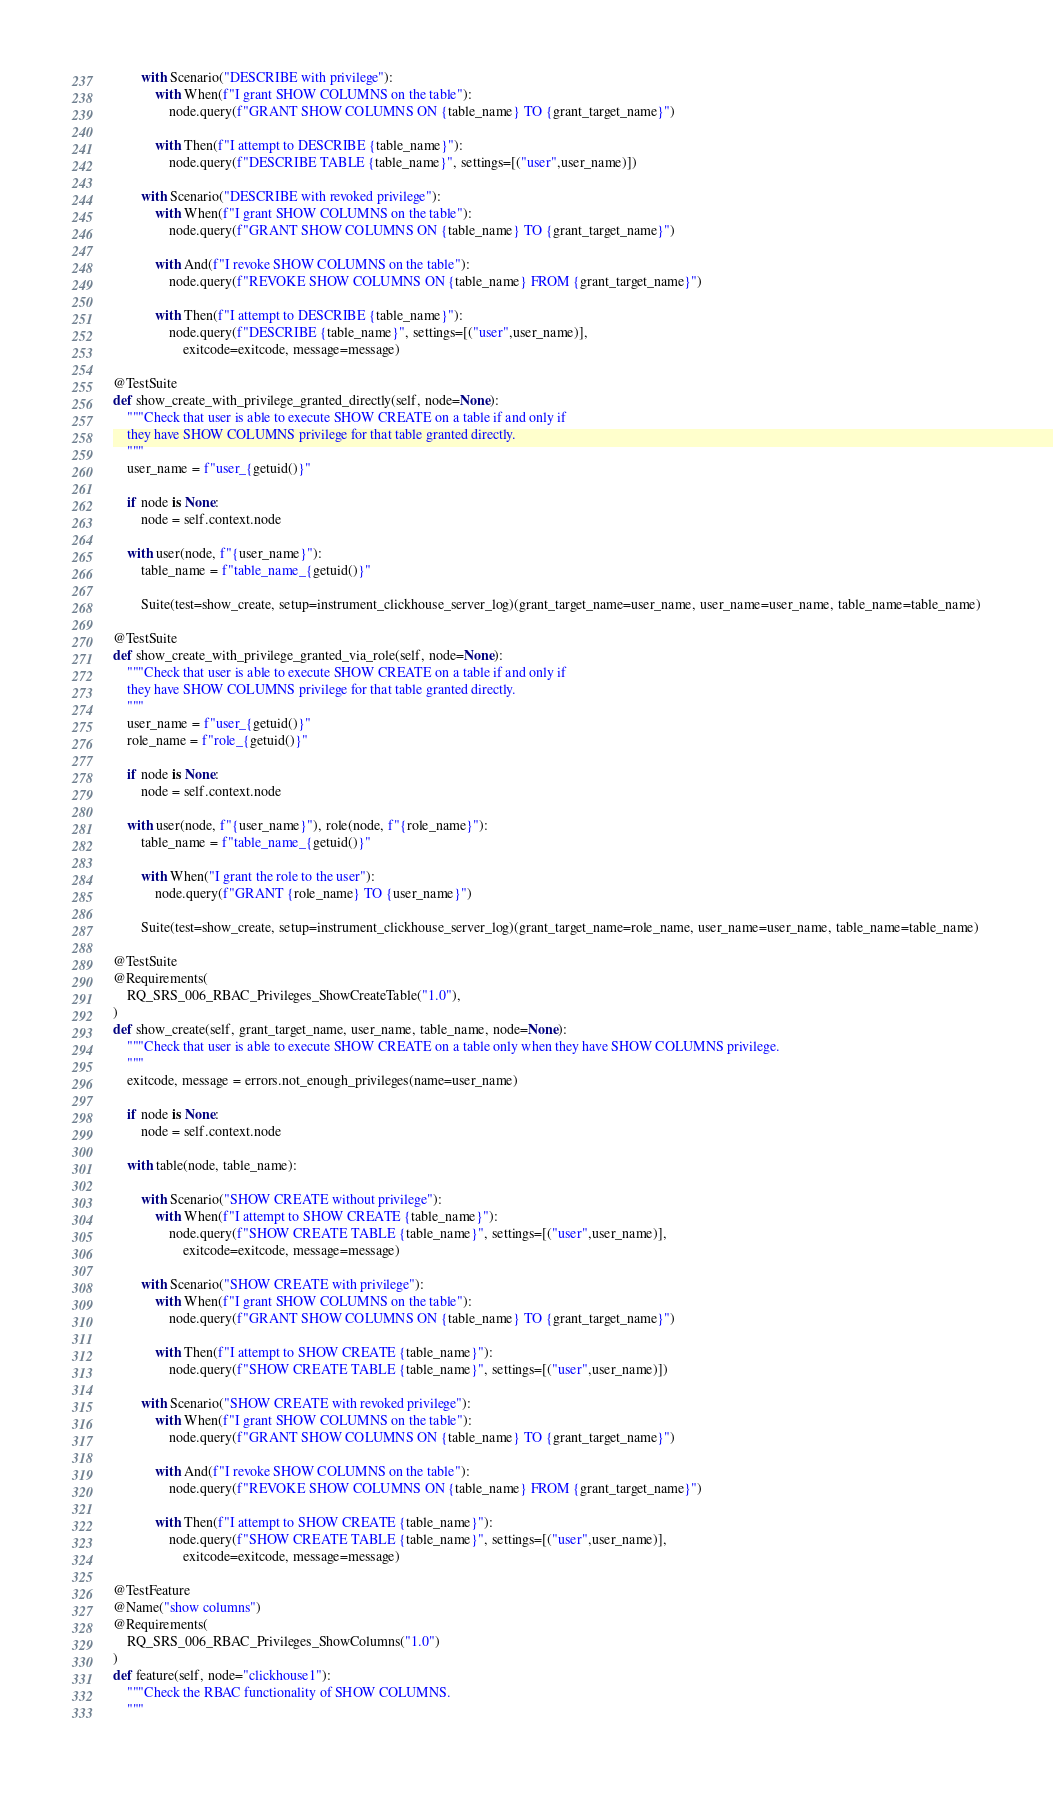Convert code to text. <code><loc_0><loc_0><loc_500><loc_500><_Python_>        with Scenario("DESCRIBE with privilege"):
            with When(f"I grant SHOW COLUMNS on the table"):
                node.query(f"GRANT SHOW COLUMNS ON {table_name} TO {grant_target_name}")

            with Then(f"I attempt to DESCRIBE {table_name}"):
                node.query(f"DESCRIBE TABLE {table_name}", settings=[("user",user_name)])

        with Scenario("DESCRIBE with revoked privilege"):
            with When(f"I grant SHOW COLUMNS on the table"):
                node.query(f"GRANT SHOW COLUMNS ON {table_name} TO {grant_target_name}")

            with And(f"I revoke SHOW COLUMNS on the table"):
                node.query(f"REVOKE SHOW COLUMNS ON {table_name} FROM {grant_target_name}")

            with Then(f"I attempt to DESCRIBE {table_name}"):
                node.query(f"DESCRIBE {table_name}", settings=[("user",user_name)],
                    exitcode=exitcode, message=message)

@TestSuite
def show_create_with_privilege_granted_directly(self, node=None):
    """Check that user is able to execute SHOW CREATE on a table if and only if
    they have SHOW COLUMNS privilege for that table granted directly.
    """
    user_name = f"user_{getuid()}"

    if node is None:
        node = self.context.node

    with user(node, f"{user_name}"):
        table_name = f"table_name_{getuid()}"

        Suite(test=show_create, setup=instrument_clickhouse_server_log)(grant_target_name=user_name, user_name=user_name, table_name=table_name)

@TestSuite
def show_create_with_privilege_granted_via_role(self, node=None):
    """Check that user is able to execute SHOW CREATE on a table if and only if
    they have SHOW COLUMNS privilege for that table granted directly.
    """
    user_name = f"user_{getuid()}"
    role_name = f"role_{getuid()}"

    if node is None:
        node = self.context.node

    with user(node, f"{user_name}"), role(node, f"{role_name}"):
        table_name = f"table_name_{getuid()}"

        with When("I grant the role to the user"):
            node.query(f"GRANT {role_name} TO {user_name}")

        Suite(test=show_create, setup=instrument_clickhouse_server_log)(grant_target_name=role_name, user_name=user_name, table_name=table_name)

@TestSuite
@Requirements(
    RQ_SRS_006_RBAC_Privileges_ShowCreateTable("1.0"),
)
def show_create(self, grant_target_name, user_name, table_name, node=None):
    """Check that user is able to execute SHOW CREATE on a table only when they have SHOW COLUMNS privilege.
    """
    exitcode, message = errors.not_enough_privileges(name=user_name)

    if node is None:
        node = self.context.node

    with table(node, table_name):

        with Scenario("SHOW CREATE without privilege"):
            with When(f"I attempt to SHOW CREATE {table_name}"):
                node.query(f"SHOW CREATE TABLE {table_name}", settings=[("user",user_name)],
                    exitcode=exitcode, message=message)

        with Scenario("SHOW CREATE with privilege"):
            with When(f"I grant SHOW COLUMNS on the table"):
                node.query(f"GRANT SHOW COLUMNS ON {table_name} TO {grant_target_name}")

            with Then(f"I attempt to SHOW CREATE {table_name}"):
                node.query(f"SHOW CREATE TABLE {table_name}", settings=[("user",user_name)])

        with Scenario("SHOW CREATE with revoked privilege"):
            with When(f"I grant SHOW COLUMNS on the table"):
                node.query(f"GRANT SHOW COLUMNS ON {table_name} TO {grant_target_name}")

            with And(f"I revoke SHOW COLUMNS on the table"):
                node.query(f"REVOKE SHOW COLUMNS ON {table_name} FROM {grant_target_name}")

            with Then(f"I attempt to SHOW CREATE {table_name}"):
                node.query(f"SHOW CREATE TABLE {table_name}", settings=[("user",user_name)],
                    exitcode=exitcode, message=message)

@TestFeature
@Name("show columns")
@Requirements(
    RQ_SRS_006_RBAC_Privileges_ShowColumns("1.0")
)
def feature(self, node="clickhouse1"):
    """Check the RBAC functionality of SHOW COLUMNS.
    """</code> 